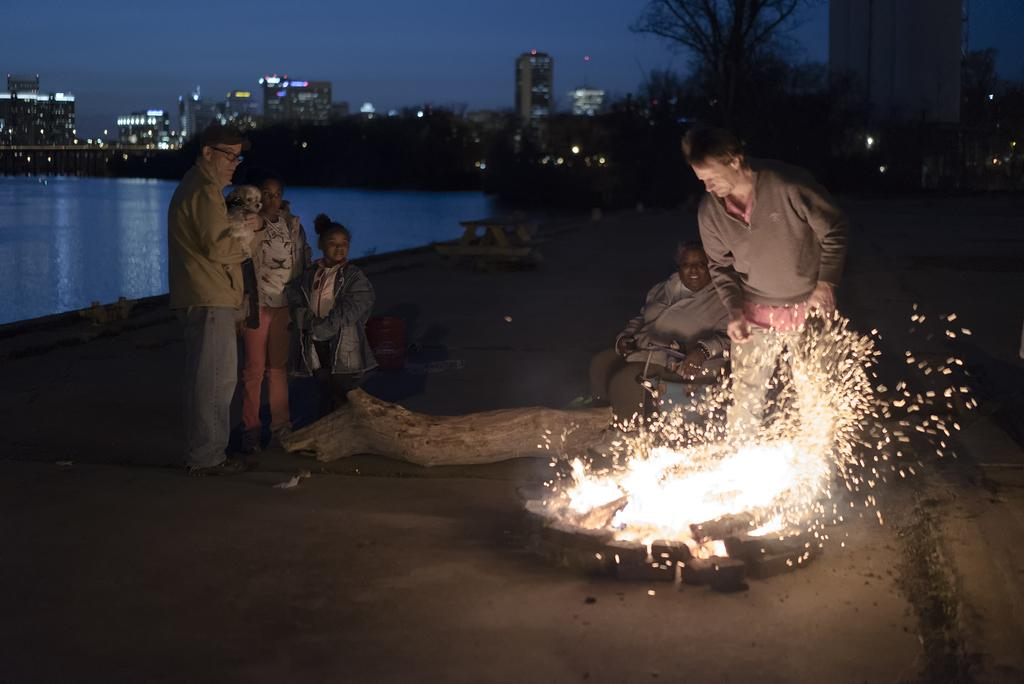How many people are in the image? There are people in the image, but the exact number is not specified. What is the source of the fire in the image? The facts do not specify the source of the fire. What is the wooden object in the image made of? The wooden object in the image is made of wood. What is the water in the image used for? The facts do not specify the purpose of the water in the image. What can be seen in the background of the image? In the background of the image, there are trees, buildings, lights, and the sky. What type of watch is the person wearing in the image? There is no mention of a watch or any person wearing a watch in the image. What does the person hate in the image? There is no information about a person's feelings or dislikes in the image. 